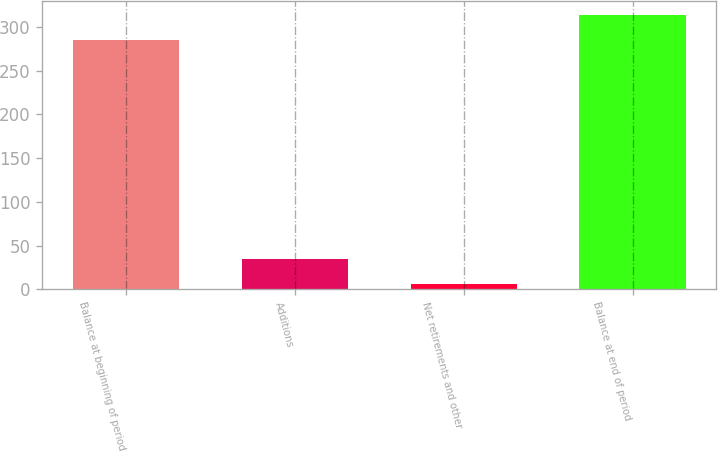<chart> <loc_0><loc_0><loc_500><loc_500><bar_chart><fcel>Balance at beginning of period<fcel>Additions<fcel>Net retirements and other<fcel>Balance at end of period<nl><fcel>285<fcel>34.5<fcel>6<fcel>313.5<nl></chart> 